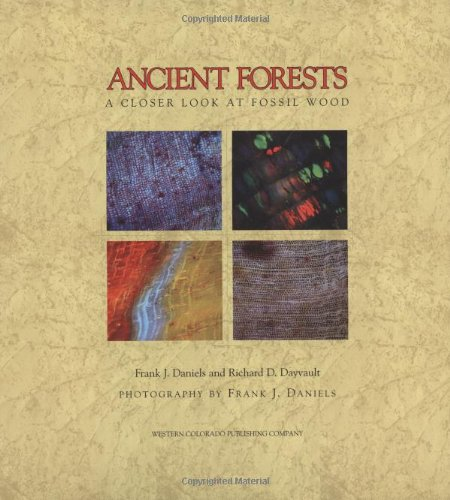Who is the author of this book? The book 'Ancient Forests: A Closer Look at Fossil Wood' is co-authored by Frank J. Daniels and Richard D. Dayvault, who bring a combined expertise in paleontology and photography to explore the fascinating details of fossilized wood. 